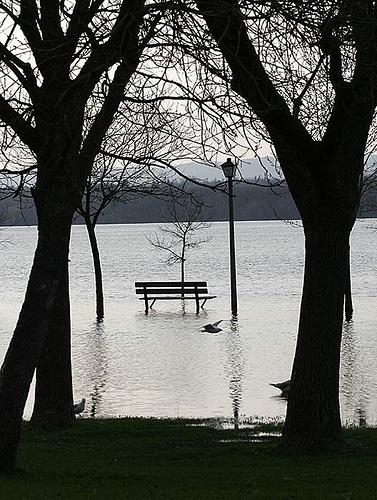Describe the objects in this image and their specific colors. I can see bench in black, lightgray, darkgray, and gray tones, bird in black, white, gray, and darkgray tones, bird in black, gray, ivory, and darkgray tones, and bird in black, white, gray, and darkgray tones in this image. 